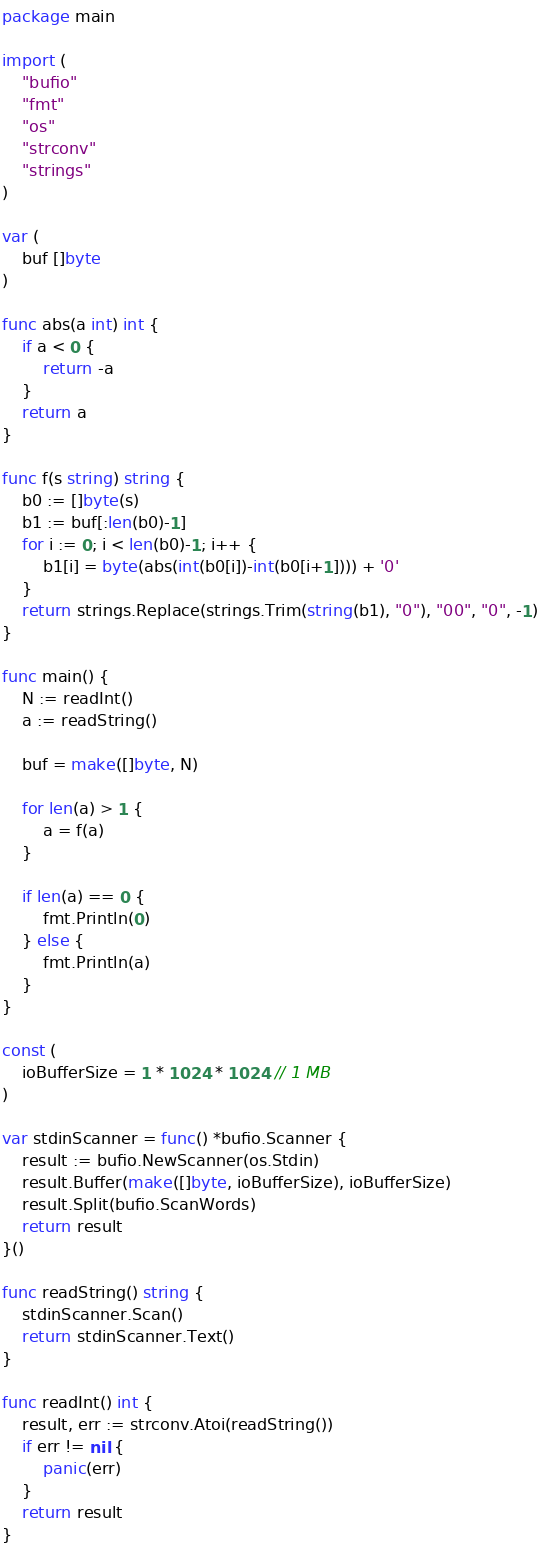Convert code to text. <code><loc_0><loc_0><loc_500><loc_500><_Go_>package main

import (
	"bufio"
	"fmt"
	"os"
	"strconv"
	"strings"
)

var (
	buf []byte
)

func abs(a int) int {
	if a < 0 {
		return -a
	}
	return a
}

func f(s string) string {
	b0 := []byte(s)
	b1 := buf[:len(b0)-1]
	for i := 0; i < len(b0)-1; i++ {
		b1[i] = byte(abs(int(b0[i])-int(b0[i+1]))) + '0'
	}
	return strings.Replace(strings.Trim(string(b1), "0"), "00", "0", -1)
}

func main() {
	N := readInt()
	a := readString()

	buf = make([]byte, N)

	for len(a) > 1 {
		a = f(a)
	}

	if len(a) == 0 {
		fmt.Println(0)
	} else {
		fmt.Println(a)
	}
}

const (
	ioBufferSize = 1 * 1024 * 1024 // 1 MB
)

var stdinScanner = func() *bufio.Scanner {
	result := bufio.NewScanner(os.Stdin)
	result.Buffer(make([]byte, ioBufferSize), ioBufferSize)
	result.Split(bufio.ScanWords)
	return result
}()

func readString() string {
	stdinScanner.Scan()
	return stdinScanner.Text()
}

func readInt() int {
	result, err := strconv.Atoi(readString())
	if err != nil {
		panic(err)
	}
	return result
}
</code> 